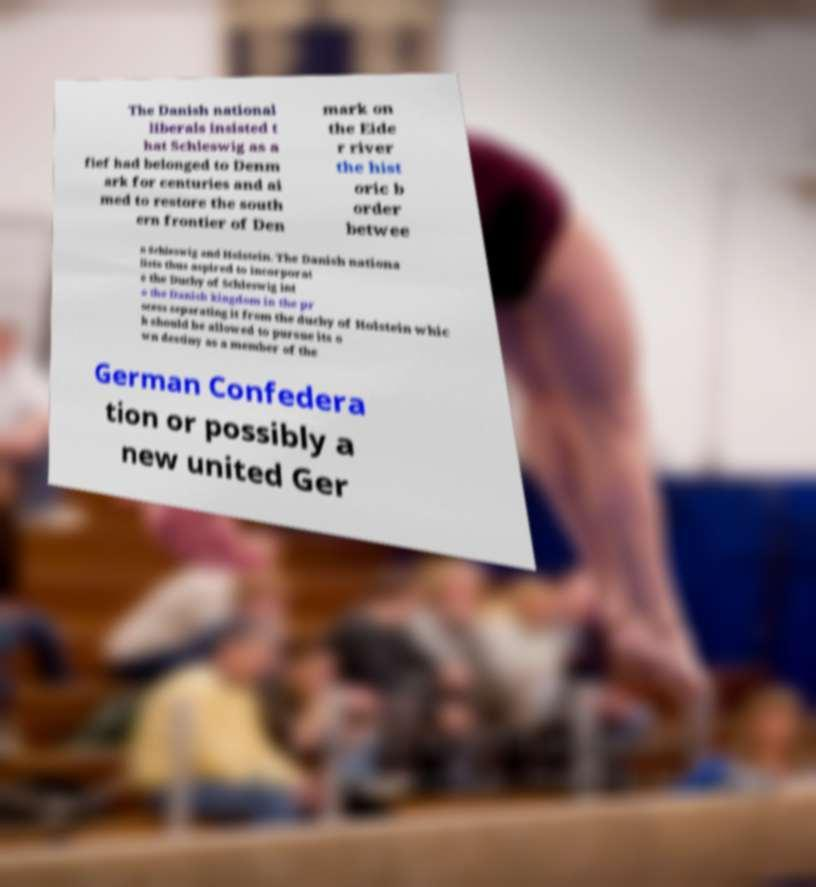Please read and relay the text visible in this image. What does it say? The Danish national liberals insisted t hat Schleswig as a fief had belonged to Denm ark for centuries and ai med to restore the south ern frontier of Den mark on the Eide r river the hist oric b order betwee n Schleswig and Holstein. The Danish nationa lists thus aspired to incorporat e the Duchy of Schleswig int o the Danish kingdom in the pr ocess separating it from the duchy of Holstein whic h should be allowed to pursue its o wn destiny as a member of the German Confedera tion or possibly a new united Ger 